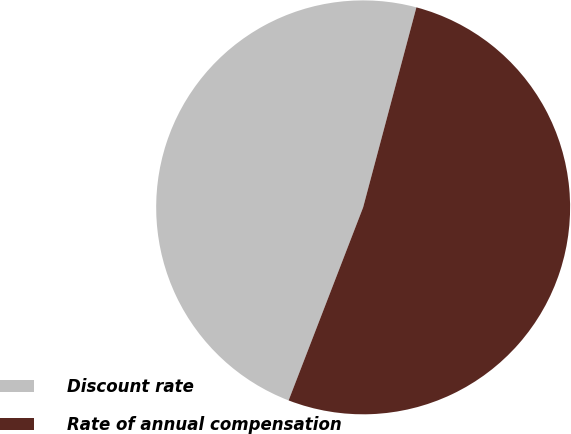Convert chart. <chart><loc_0><loc_0><loc_500><loc_500><pie_chart><fcel>Discount rate<fcel>Rate of annual compensation<nl><fcel>48.28%<fcel>51.72%<nl></chart> 